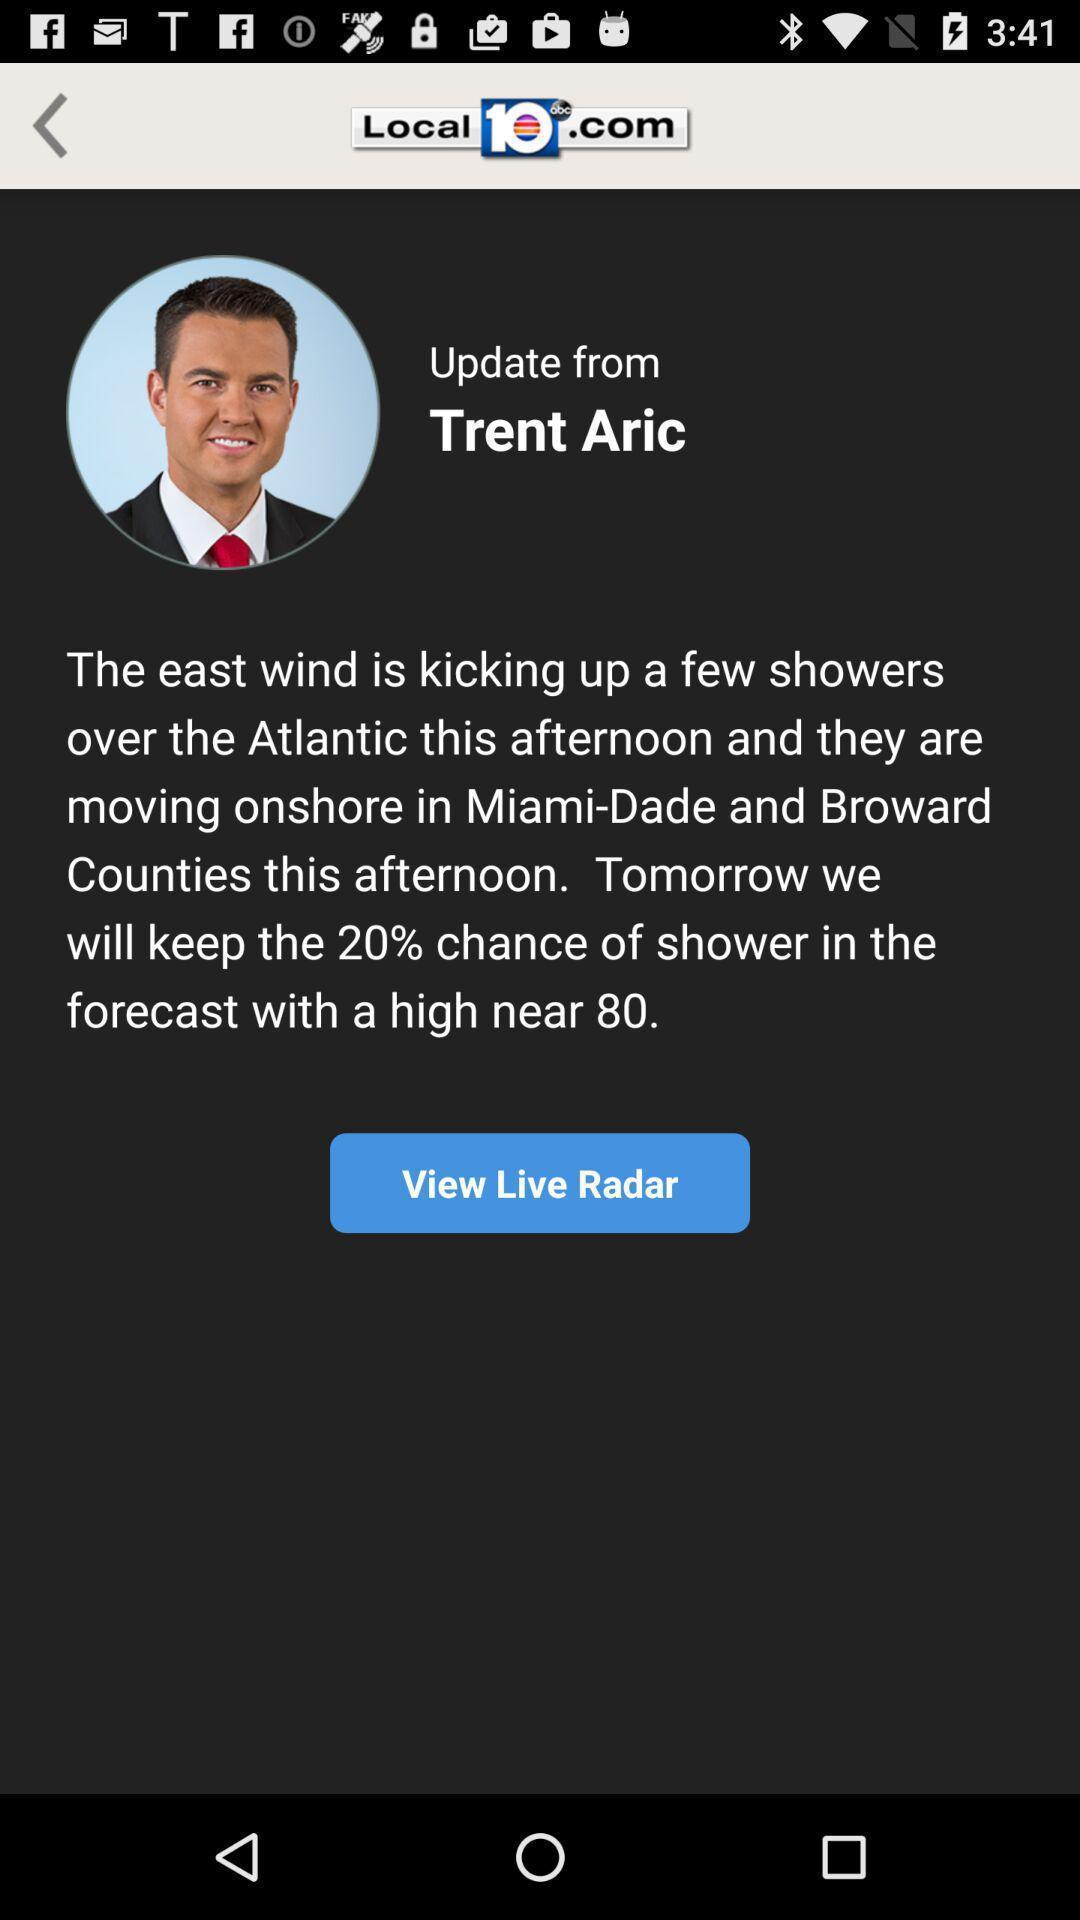Explain the elements present in this screenshot. Page displays the news article about a person. 